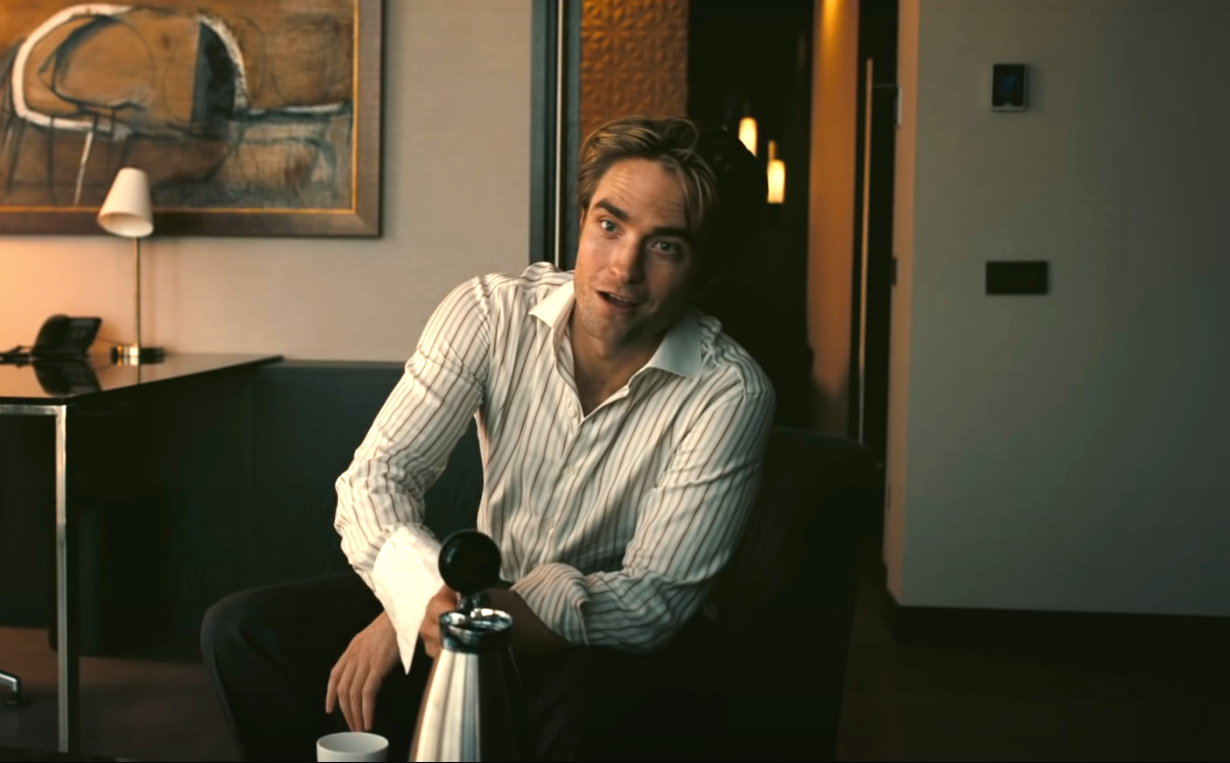Imagine this is a scene from a movie. What could be the plot around this moment? In this imagined movie scene, the man could be a character reflecting on a significant decision. Perhaps he has just made a pivotal choice that will impact his future drastically—maybe he decided to leave a high-powered job to pursue his passion. As he sits on the couch, the silver water pitcher symbolizing a new, simple life, he contemplates the uncertainty and excitement of this new venture. The serene and sophisticated setting underscores the internal peace he feels despite the risks involved in his decision. 